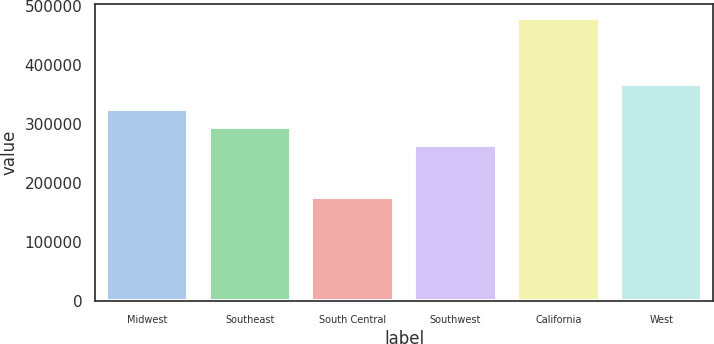<chart> <loc_0><loc_0><loc_500><loc_500><bar_chart><fcel>Midwest<fcel>Southeast<fcel>South Central<fcel>Southwest<fcel>California<fcel>West<nl><fcel>325840<fcel>295420<fcel>176200<fcel>265000<fcel>480400<fcel>368200<nl></chart> 